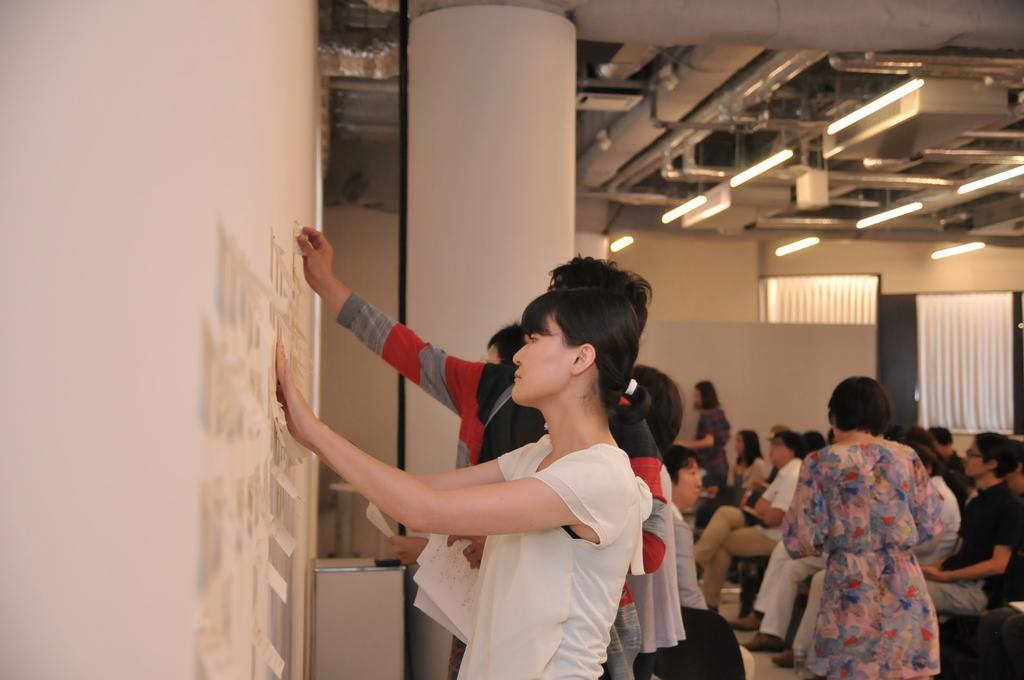Could you give a brief overview of what you see in this image? In this image we can see some persons, papers and other objects. In the background of the image there is a wall, curtain and other objects. At the top of the image there is the roof, lights and other objects. On the left side of the image there is a wall and papers. 